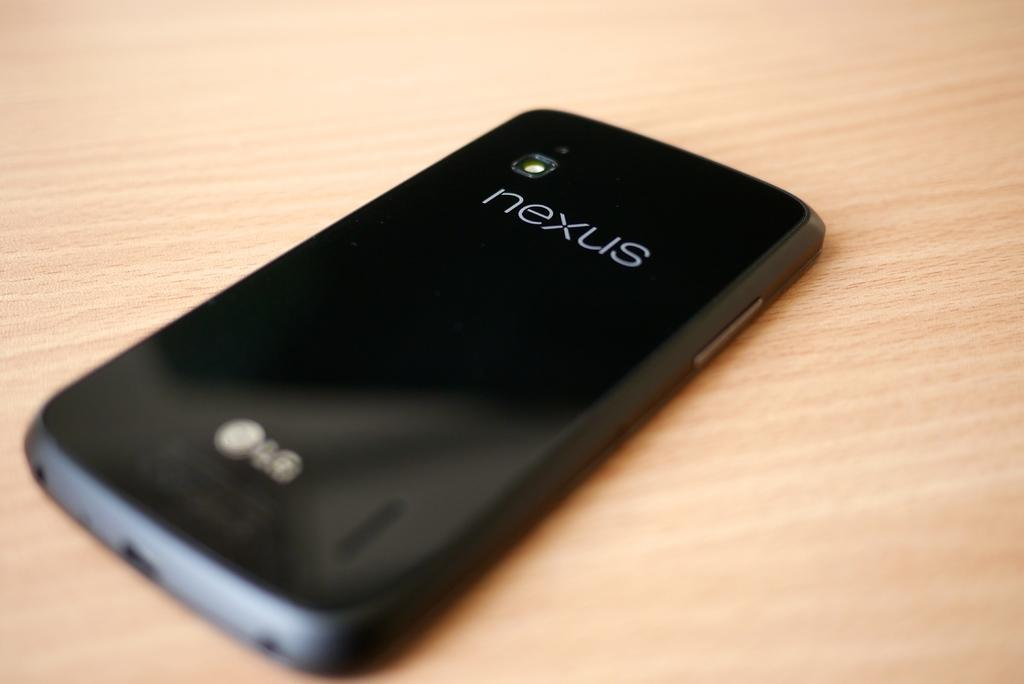Provide a one-sentence caption for the provided image. A nexus smart phone rests on a table top. 